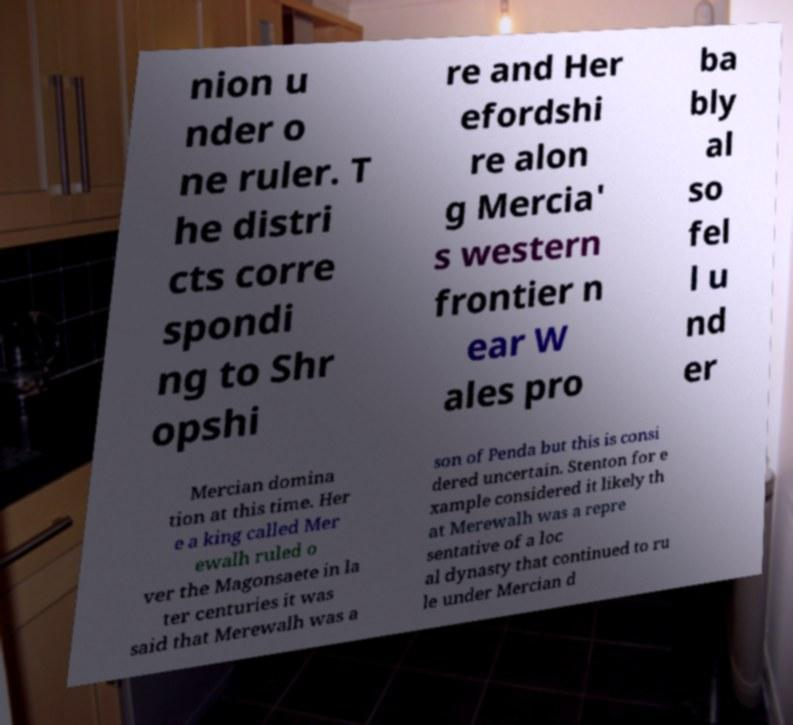Can you accurately transcribe the text from the provided image for me? nion u nder o ne ruler. T he distri cts corre spondi ng to Shr opshi re and Her efordshi re alon g Mercia' s western frontier n ear W ales pro ba bly al so fel l u nd er Mercian domina tion at this time. Her e a king called Mer ewalh ruled o ver the Magonsaete in la ter centuries it was said that Merewalh was a son of Penda but this is consi dered uncertain. Stenton for e xample considered it likely th at Merewalh was a repre sentative of a loc al dynasty that continued to ru le under Mercian d 